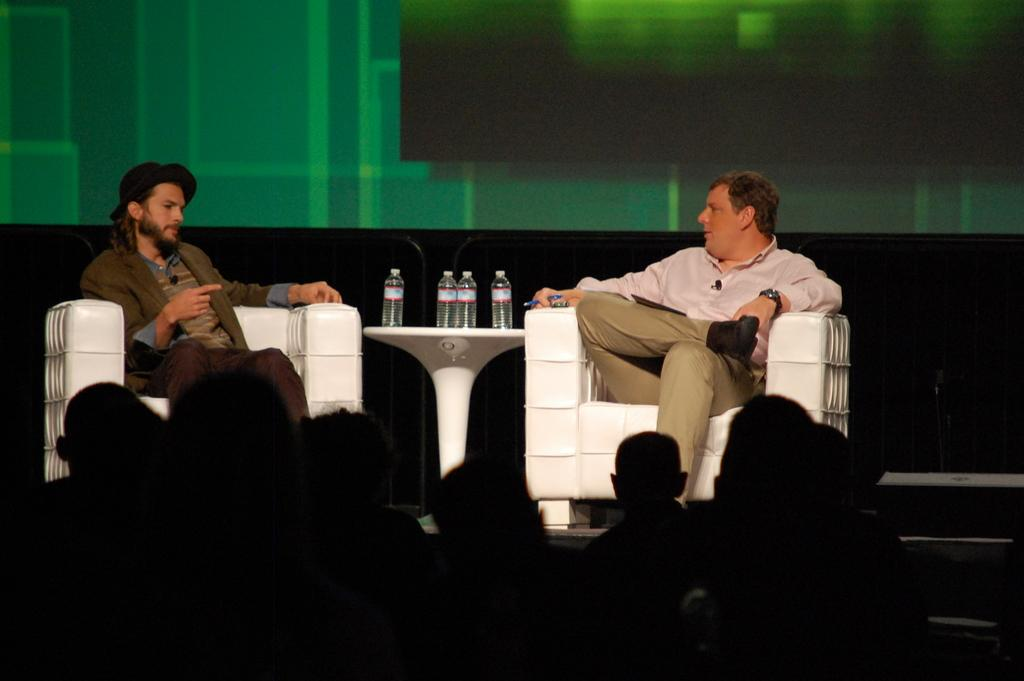What are the two people in the image doing? The two people are sitting on a couch in the center of the image. What is located between the two people on the couch? There is a stand between the two people on the couch. What is placed on the stand? Bottles are placed on the stand. What can be seen in the background of the image? There is a crowd visible at the bottom of the image. What type of harmony is being played by the texture of the ground in the image? There is no mention of harmony or texture of the ground in the image; it only features two people sitting on a couch with a stand and bottles between them, and a crowd in the background. 